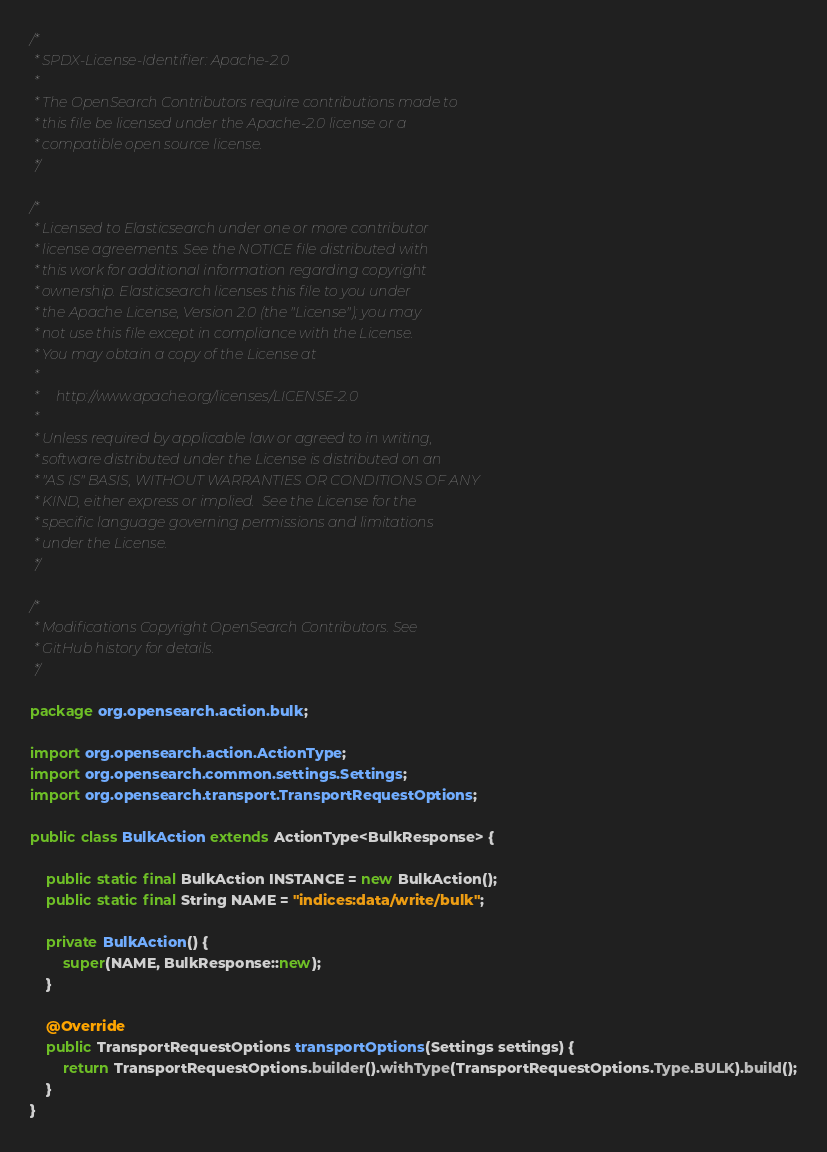Convert code to text. <code><loc_0><loc_0><loc_500><loc_500><_Java_>/*
 * SPDX-License-Identifier: Apache-2.0
 *
 * The OpenSearch Contributors require contributions made to
 * this file be licensed under the Apache-2.0 license or a
 * compatible open source license.
 */

/*
 * Licensed to Elasticsearch under one or more contributor
 * license agreements. See the NOTICE file distributed with
 * this work for additional information regarding copyright
 * ownership. Elasticsearch licenses this file to you under
 * the Apache License, Version 2.0 (the "License"); you may
 * not use this file except in compliance with the License.
 * You may obtain a copy of the License at
 *
 *     http://www.apache.org/licenses/LICENSE-2.0
 *
 * Unless required by applicable law or agreed to in writing,
 * software distributed under the License is distributed on an
 * "AS IS" BASIS, WITHOUT WARRANTIES OR CONDITIONS OF ANY
 * KIND, either express or implied.  See the License for the
 * specific language governing permissions and limitations
 * under the License.
 */

/*
 * Modifications Copyright OpenSearch Contributors. See
 * GitHub history for details.
 */

package org.opensearch.action.bulk;

import org.opensearch.action.ActionType;
import org.opensearch.common.settings.Settings;
import org.opensearch.transport.TransportRequestOptions;

public class BulkAction extends ActionType<BulkResponse> {

    public static final BulkAction INSTANCE = new BulkAction();
    public static final String NAME = "indices:data/write/bulk";

    private BulkAction() {
        super(NAME, BulkResponse::new);
    }

    @Override
    public TransportRequestOptions transportOptions(Settings settings) {
        return TransportRequestOptions.builder().withType(TransportRequestOptions.Type.BULK).build();
    }
}
</code> 